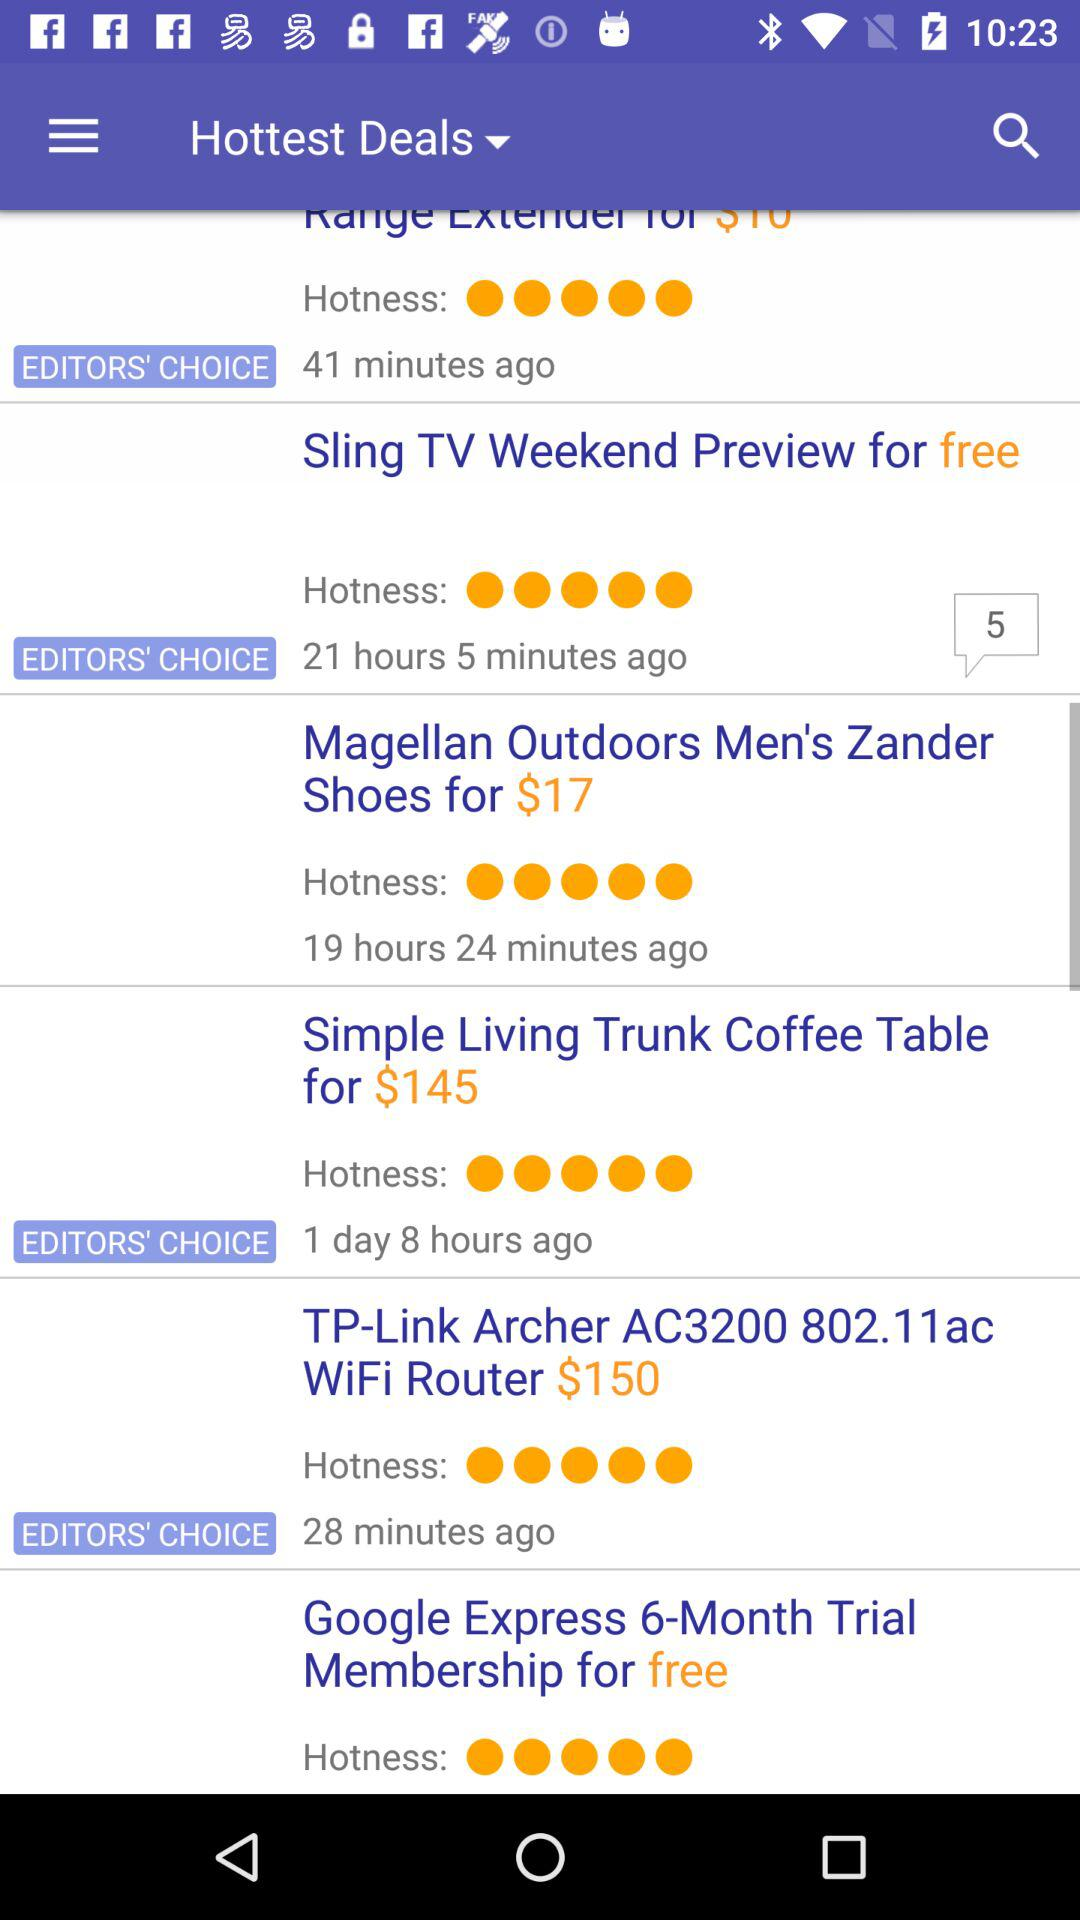What is the price of the "Simple Living Trunk Coffee Table"? The price is $145. 